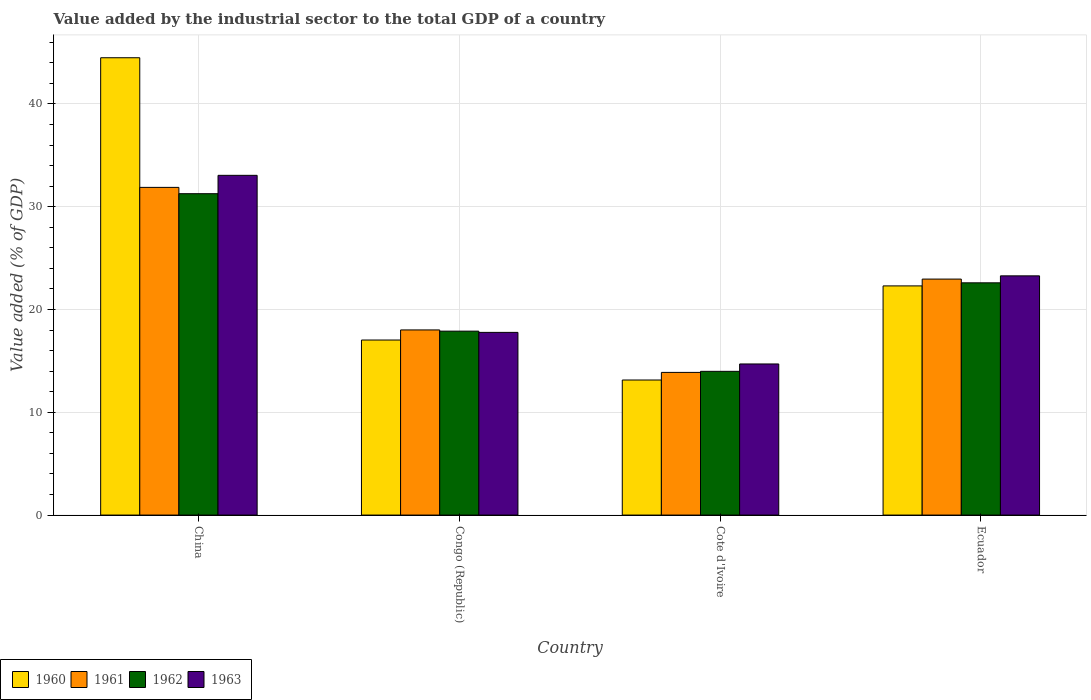How many different coloured bars are there?
Your response must be concise. 4. How many groups of bars are there?
Keep it short and to the point. 4. Are the number of bars on each tick of the X-axis equal?
Your answer should be very brief. Yes. What is the label of the 3rd group of bars from the left?
Your response must be concise. Cote d'Ivoire. What is the value added by the industrial sector to the total GDP in 1960 in Ecuador?
Offer a very short reply. 22.29. Across all countries, what is the maximum value added by the industrial sector to the total GDP in 1960?
Offer a terse response. 44.49. Across all countries, what is the minimum value added by the industrial sector to the total GDP in 1961?
Offer a terse response. 13.88. In which country was the value added by the industrial sector to the total GDP in 1963 minimum?
Ensure brevity in your answer.  Cote d'Ivoire. What is the total value added by the industrial sector to the total GDP in 1963 in the graph?
Your answer should be very brief. 88.79. What is the difference between the value added by the industrial sector to the total GDP in 1960 in Congo (Republic) and that in Ecuador?
Make the answer very short. -5.27. What is the difference between the value added by the industrial sector to the total GDP in 1962 in Congo (Republic) and the value added by the industrial sector to the total GDP in 1960 in Ecuador?
Your answer should be compact. -4.4. What is the average value added by the industrial sector to the total GDP in 1963 per country?
Your response must be concise. 22.2. What is the difference between the value added by the industrial sector to the total GDP of/in 1963 and value added by the industrial sector to the total GDP of/in 1962 in China?
Provide a succinct answer. 1.79. In how many countries, is the value added by the industrial sector to the total GDP in 1960 greater than 30 %?
Keep it short and to the point. 1. What is the ratio of the value added by the industrial sector to the total GDP in 1961 in Congo (Republic) to that in Cote d'Ivoire?
Your answer should be very brief. 1.3. Is the value added by the industrial sector to the total GDP in 1960 in China less than that in Ecuador?
Your answer should be very brief. No. Is the difference between the value added by the industrial sector to the total GDP in 1963 in China and Cote d'Ivoire greater than the difference between the value added by the industrial sector to the total GDP in 1962 in China and Cote d'Ivoire?
Your answer should be very brief. Yes. What is the difference between the highest and the second highest value added by the industrial sector to the total GDP in 1960?
Provide a succinct answer. -27.46. What is the difference between the highest and the lowest value added by the industrial sector to the total GDP in 1963?
Your answer should be very brief. 18.35. In how many countries, is the value added by the industrial sector to the total GDP in 1961 greater than the average value added by the industrial sector to the total GDP in 1961 taken over all countries?
Keep it short and to the point. 2. What does the 2nd bar from the right in Ecuador represents?
Make the answer very short. 1962. Is it the case that in every country, the sum of the value added by the industrial sector to the total GDP in 1963 and value added by the industrial sector to the total GDP in 1961 is greater than the value added by the industrial sector to the total GDP in 1960?
Make the answer very short. Yes. How many bars are there?
Your answer should be compact. 16. What is the difference between two consecutive major ticks on the Y-axis?
Ensure brevity in your answer.  10. How many legend labels are there?
Offer a terse response. 4. What is the title of the graph?
Offer a very short reply. Value added by the industrial sector to the total GDP of a country. Does "1997" appear as one of the legend labels in the graph?
Your answer should be compact. No. What is the label or title of the X-axis?
Ensure brevity in your answer.  Country. What is the label or title of the Y-axis?
Provide a succinct answer. Value added (% of GDP). What is the Value added (% of GDP) in 1960 in China?
Your answer should be compact. 44.49. What is the Value added (% of GDP) of 1961 in China?
Your answer should be compact. 31.88. What is the Value added (% of GDP) in 1962 in China?
Provide a succinct answer. 31.26. What is the Value added (% of GDP) of 1963 in China?
Give a very brief answer. 33.05. What is the Value added (% of GDP) in 1960 in Congo (Republic)?
Your answer should be very brief. 17.03. What is the Value added (% of GDP) of 1961 in Congo (Republic)?
Make the answer very short. 18.01. What is the Value added (% of GDP) of 1962 in Congo (Republic)?
Your answer should be very brief. 17.89. What is the Value added (% of GDP) of 1963 in Congo (Republic)?
Give a very brief answer. 17.77. What is the Value added (% of GDP) in 1960 in Cote d'Ivoire?
Make the answer very short. 13.14. What is the Value added (% of GDP) of 1961 in Cote d'Ivoire?
Give a very brief answer. 13.88. What is the Value added (% of GDP) of 1962 in Cote d'Ivoire?
Your response must be concise. 13.98. What is the Value added (% of GDP) in 1963 in Cote d'Ivoire?
Give a very brief answer. 14.7. What is the Value added (% of GDP) of 1960 in Ecuador?
Provide a short and direct response. 22.29. What is the Value added (% of GDP) in 1961 in Ecuador?
Give a very brief answer. 22.96. What is the Value added (% of GDP) of 1962 in Ecuador?
Your answer should be very brief. 22.59. What is the Value added (% of GDP) of 1963 in Ecuador?
Give a very brief answer. 23.27. Across all countries, what is the maximum Value added (% of GDP) in 1960?
Provide a short and direct response. 44.49. Across all countries, what is the maximum Value added (% of GDP) of 1961?
Give a very brief answer. 31.88. Across all countries, what is the maximum Value added (% of GDP) in 1962?
Provide a succinct answer. 31.26. Across all countries, what is the maximum Value added (% of GDP) in 1963?
Keep it short and to the point. 33.05. Across all countries, what is the minimum Value added (% of GDP) of 1960?
Offer a terse response. 13.14. Across all countries, what is the minimum Value added (% of GDP) in 1961?
Offer a terse response. 13.88. Across all countries, what is the minimum Value added (% of GDP) in 1962?
Your answer should be compact. 13.98. Across all countries, what is the minimum Value added (% of GDP) of 1963?
Provide a short and direct response. 14.7. What is the total Value added (% of GDP) in 1960 in the graph?
Offer a very short reply. 96.95. What is the total Value added (% of GDP) in 1961 in the graph?
Keep it short and to the point. 86.72. What is the total Value added (% of GDP) of 1962 in the graph?
Provide a succinct answer. 85.73. What is the total Value added (% of GDP) of 1963 in the graph?
Your answer should be compact. 88.79. What is the difference between the Value added (% of GDP) of 1960 in China and that in Congo (Republic)?
Offer a very short reply. 27.46. What is the difference between the Value added (% of GDP) of 1961 in China and that in Congo (Republic)?
Make the answer very short. 13.87. What is the difference between the Value added (% of GDP) of 1962 in China and that in Congo (Republic)?
Your answer should be very brief. 13.37. What is the difference between the Value added (% of GDP) in 1963 in China and that in Congo (Republic)?
Ensure brevity in your answer.  15.28. What is the difference between the Value added (% of GDP) in 1960 in China and that in Cote d'Ivoire?
Offer a very short reply. 31.35. What is the difference between the Value added (% of GDP) in 1961 in China and that in Cote d'Ivoire?
Offer a very short reply. 18. What is the difference between the Value added (% of GDP) of 1962 in China and that in Cote d'Ivoire?
Provide a succinct answer. 17.28. What is the difference between the Value added (% of GDP) of 1963 in China and that in Cote d'Ivoire?
Provide a short and direct response. 18.35. What is the difference between the Value added (% of GDP) in 1960 in China and that in Ecuador?
Give a very brief answer. 22.19. What is the difference between the Value added (% of GDP) in 1961 in China and that in Ecuador?
Keep it short and to the point. 8.92. What is the difference between the Value added (% of GDP) of 1962 in China and that in Ecuador?
Your answer should be compact. 8.67. What is the difference between the Value added (% of GDP) of 1963 in China and that in Ecuador?
Offer a terse response. 9.78. What is the difference between the Value added (% of GDP) in 1960 in Congo (Republic) and that in Cote d'Ivoire?
Keep it short and to the point. 3.89. What is the difference between the Value added (% of GDP) in 1961 in Congo (Republic) and that in Cote d'Ivoire?
Offer a very short reply. 4.13. What is the difference between the Value added (% of GDP) of 1962 in Congo (Republic) and that in Cote d'Ivoire?
Make the answer very short. 3.91. What is the difference between the Value added (% of GDP) in 1963 in Congo (Republic) and that in Cote d'Ivoire?
Keep it short and to the point. 3.07. What is the difference between the Value added (% of GDP) in 1960 in Congo (Republic) and that in Ecuador?
Ensure brevity in your answer.  -5.27. What is the difference between the Value added (% of GDP) in 1961 in Congo (Republic) and that in Ecuador?
Offer a very short reply. -4.95. What is the difference between the Value added (% of GDP) of 1962 in Congo (Republic) and that in Ecuador?
Offer a terse response. -4.7. What is the difference between the Value added (% of GDP) in 1963 in Congo (Republic) and that in Ecuador?
Ensure brevity in your answer.  -5.5. What is the difference between the Value added (% of GDP) in 1960 in Cote d'Ivoire and that in Ecuador?
Give a very brief answer. -9.16. What is the difference between the Value added (% of GDP) in 1961 in Cote d'Ivoire and that in Ecuador?
Make the answer very short. -9.08. What is the difference between the Value added (% of GDP) of 1962 in Cote d'Ivoire and that in Ecuador?
Offer a very short reply. -8.61. What is the difference between the Value added (% of GDP) in 1963 in Cote d'Ivoire and that in Ecuador?
Offer a terse response. -8.57. What is the difference between the Value added (% of GDP) in 1960 in China and the Value added (% of GDP) in 1961 in Congo (Republic)?
Provide a short and direct response. 26.48. What is the difference between the Value added (% of GDP) of 1960 in China and the Value added (% of GDP) of 1962 in Congo (Republic)?
Your answer should be very brief. 26.6. What is the difference between the Value added (% of GDP) of 1960 in China and the Value added (% of GDP) of 1963 in Congo (Republic)?
Ensure brevity in your answer.  26.72. What is the difference between the Value added (% of GDP) in 1961 in China and the Value added (% of GDP) in 1962 in Congo (Republic)?
Your answer should be very brief. 13.98. What is the difference between the Value added (% of GDP) of 1961 in China and the Value added (% of GDP) of 1963 in Congo (Republic)?
Provide a succinct answer. 14.1. What is the difference between the Value added (% of GDP) in 1962 in China and the Value added (% of GDP) in 1963 in Congo (Republic)?
Your response must be concise. 13.49. What is the difference between the Value added (% of GDP) in 1960 in China and the Value added (% of GDP) in 1961 in Cote d'Ivoire?
Your answer should be compact. 30.61. What is the difference between the Value added (% of GDP) in 1960 in China and the Value added (% of GDP) in 1962 in Cote d'Ivoire?
Offer a terse response. 30.51. What is the difference between the Value added (% of GDP) of 1960 in China and the Value added (% of GDP) of 1963 in Cote d'Ivoire?
Your answer should be compact. 29.79. What is the difference between the Value added (% of GDP) of 1961 in China and the Value added (% of GDP) of 1962 in Cote d'Ivoire?
Provide a succinct answer. 17.9. What is the difference between the Value added (% of GDP) in 1961 in China and the Value added (% of GDP) in 1963 in Cote d'Ivoire?
Provide a succinct answer. 17.18. What is the difference between the Value added (% of GDP) in 1962 in China and the Value added (% of GDP) in 1963 in Cote d'Ivoire?
Your answer should be compact. 16.56. What is the difference between the Value added (% of GDP) of 1960 in China and the Value added (% of GDP) of 1961 in Ecuador?
Your answer should be compact. 21.53. What is the difference between the Value added (% of GDP) of 1960 in China and the Value added (% of GDP) of 1962 in Ecuador?
Your answer should be very brief. 21.9. What is the difference between the Value added (% of GDP) of 1960 in China and the Value added (% of GDP) of 1963 in Ecuador?
Your response must be concise. 21.22. What is the difference between the Value added (% of GDP) in 1961 in China and the Value added (% of GDP) in 1962 in Ecuador?
Your response must be concise. 9.28. What is the difference between the Value added (% of GDP) of 1961 in China and the Value added (% of GDP) of 1963 in Ecuador?
Keep it short and to the point. 8.61. What is the difference between the Value added (% of GDP) in 1962 in China and the Value added (% of GDP) in 1963 in Ecuador?
Provide a succinct answer. 7.99. What is the difference between the Value added (% of GDP) of 1960 in Congo (Republic) and the Value added (% of GDP) of 1961 in Cote d'Ivoire?
Your answer should be compact. 3.15. What is the difference between the Value added (% of GDP) of 1960 in Congo (Republic) and the Value added (% of GDP) of 1962 in Cote d'Ivoire?
Give a very brief answer. 3.05. What is the difference between the Value added (% of GDP) of 1960 in Congo (Republic) and the Value added (% of GDP) of 1963 in Cote d'Ivoire?
Provide a succinct answer. 2.33. What is the difference between the Value added (% of GDP) of 1961 in Congo (Republic) and the Value added (% of GDP) of 1962 in Cote d'Ivoire?
Provide a short and direct response. 4.03. What is the difference between the Value added (% of GDP) of 1961 in Congo (Republic) and the Value added (% of GDP) of 1963 in Cote d'Ivoire?
Offer a terse response. 3.31. What is the difference between the Value added (% of GDP) of 1962 in Congo (Republic) and the Value added (% of GDP) of 1963 in Cote d'Ivoire?
Your answer should be very brief. 3.19. What is the difference between the Value added (% of GDP) of 1960 in Congo (Republic) and the Value added (% of GDP) of 1961 in Ecuador?
Give a very brief answer. -5.93. What is the difference between the Value added (% of GDP) in 1960 in Congo (Republic) and the Value added (% of GDP) in 1962 in Ecuador?
Your answer should be compact. -5.57. What is the difference between the Value added (% of GDP) of 1960 in Congo (Republic) and the Value added (% of GDP) of 1963 in Ecuador?
Your answer should be compact. -6.24. What is the difference between the Value added (% of GDP) of 1961 in Congo (Republic) and the Value added (% of GDP) of 1962 in Ecuador?
Make the answer very short. -4.58. What is the difference between the Value added (% of GDP) in 1961 in Congo (Republic) and the Value added (% of GDP) in 1963 in Ecuador?
Keep it short and to the point. -5.26. What is the difference between the Value added (% of GDP) of 1962 in Congo (Republic) and the Value added (% of GDP) of 1963 in Ecuador?
Your answer should be compact. -5.38. What is the difference between the Value added (% of GDP) in 1960 in Cote d'Ivoire and the Value added (% of GDP) in 1961 in Ecuador?
Your answer should be very brief. -9.82. What is the difference between the Value added (% of GDP) of 1960 in Cote d'Ivoire and the Value added (% of GDP) of 1962 in Ecuador?
Keep it short and to the point. -9.45. What is the difference between the Value added (% of GDP) of 1960 in Cote d'Ivoire and the Value added (% of GDP) of 1963 in Ecuador?
Keep it short and to the point. -10.13. What is the difference between the Value added (% of GDP) of 1961 in Cote d'Ivoire and the Value added (% of GDP) of 1962 in Ecuador?
Your answer should be very brief. -8.71. What is the difference between the Value added (% of GDP) of 1961 in Cote d'Ivoire and the Value added (% of GDP) of 1963 in Ecuador?
Offer a terse response. -9.39. What is the difference between the Value added (% of GDP) in 1962 in Cote d'Ivoire and the Value added (% of GDP) in 1963 in Ecuador?
Make the answer very short. -9.29. What is the average Value added (% of GDP) of 1960 per country?
Your answer should be compact. 24.24. What is the average Value added (% of GDP) in 1961 per country?
Give a very brief answer. 21.68. What is the average Value added (% of GDP) of 1962 per country?
Make the answer very short. 21.43. What is the average Value added (% of GDP) in 1963 per country?
Your answer should be compact. 22.2. What is the difference between the Value added (% of GDP) in 1960 and Value added (% of GDP) in 1961 in China?
Provide a short and direct response. 12.61. What is the difference between the Value added (% of GDP) in 1960 and Value added (% of GDP) in 1962 in China?
Your answer should be very brief. 13.23. What is the difference between the Value added (% of GDP) in 1960 and Value added (% of GDP) in 1963 in China?
Your answer should be very brief. 11.44. What is the difference between the Value added (% of GDP) of 1961 and Value added (% of GDP) of 1962 in China?
Provide a short and direct response. 0.61. What is the difference between the Value added (% of GDP) in 1961 and Value added (% of GDP) in 1963 in China?
Your answer should be very brief. -1.17. What is the difference between the Value added (% of GDP) of 1962 and Value added (% of GDP) of 1963 in China?
Give a very brief answer. -1.79. What is the difference between the Value added (% of GDP) of 1960 and Value added (% of GDP) of 1961 in Congo (Republic)?
Give a very brief answer. -0.98. What is the difference between the Value added (% of GDP) in 1960 and Value added (% of GDP) in 1962 in Congo (Republic)?
Your response must be concise. -0.86. What is the difference between the Value added (% of GDP) in 1960 and Value added (% of GDP) in 1963 in Congo (Republic)?
Provide a succinct answer. -0.74. What is the difference between the Value added (% of GDP) of 1961 and Value added (% of GDP) of 1962 in Congo (Republic)?
Your response must be concise. 0.12. What is the difference between the Value added (% of GDP) in 1961 and Value added (% of GDP) in 1963 in Congo (Republic)?
Give a very brief answer. 0.24. What is the difference between the Value added (% of GDP) of 1962 and Value added (% of GDP) of 1963 in Congo (Republic)?
Ensure brevity in your answer.  0.12. What is the difference between the Value added (% of GDP) of 1960 and Value added (% of GDP) of 1961 in Cote d'Ivoire?
Give a very brief answer. -0.74. What is the difference between the Value added (% of GDP) of 1960 and Value added (% of GDP) of 1962 in Cote d'Ivoire?
Give a very brief answer. -0.84. What is the difference between the Value added (% of GDP) of 1960 and Value added (% of GDP) of 1963 in Cote d'Ivoire?
Give a very brief answer. -1.56. What is the difference between the Value added (% of GDP) in 1961 and Value added (% of GDP) in 1962 in Cote d'Ivoire?
Your response must be concise. -0.1. What is the difference between the Value added (% of GDP) of 1961 and Value added (% of GDP) of 1963 in Cote d'Ivoire?
Make the answer very short. -0.82. What is the difference between the Value added (% of GDP) in 1962 and Value added (% of GDP) in 1963 in Cote d'Ivoire?
Ensure brevity in your answer.  -0.72. What is the difference between the Value added (% of GDP) in 1960 and Value added (% of GDP) in 1961 in Ecuador?
Your response must be concise. -0.66. What is the difference between the Value added (% of GDP) in 1960 and Value added (% of GDP) in 1962 in Ecuador?
Offer a terse response. -0.3. What is the difference between the Value added (% of GDP) in 1960 and Value added (% of GDP) in 1963 in Ecuador?
Your response must be concise. -0.98. What is the difference between the Value added (% of GDP) of 1961 and Value added (% of GDP) of 1962 in Ecuador?
Ensure brevity in your answer.  0.36. What is the difference between the Value added (% of GDP) of 1961 and Value added (% of GDP) of 1963 in Ecuador?
Provide a short and direct response. -0.31. What is the difference between the Value added (% of GDP) in 1962 and Value added (% of GDP) in 1963 in Ecuador?
Provide a succinct answer. -0.68. What is the ratio of the Value added (% of GDP) of 1960 in China to that in Congo (Republic)?
Your answer should be very brief. 2.61. What is the ratio of the Value added (% of GDP) in 1961 in China to that in Congo (Republic)?
Your answer should be compact. 1.77. What is the ratio of the Value added (% of GDP) in 1962 in China to that in Congo (Republic)?
Your response must be concise. 1.75. What is the ratio of the Value added (% of GDP) of 1963 in China to that in Congo (Republic)?
Offer a very short reply. 1.86. What is the ratio of the Value added (% of GDP) of 1960 in China to that in Cote d'Ivoire?
Provide a succinct answer. 3.39. What is the ratio of the Value added (% of GDP) in 1961 in China to that in Cote d'Ivoire?
Your answer should be very brief. 2.3. What is the ratio of the Value added (% of GDP) in 1962 in China to that in Cote d'Ivoire?
Ensure brevity in your answer.  2.24. What is the ratio of the Value added (% of GDP) of 1963 in China to that in Cote d'Ivoire?
Offer a terse response. 2.25. What is the ratio of the Value added (% of GDP) in 1960 in China to that in Ecuador?
Provide a succinct answer. 2. What is the ratio of the Value added (% of GDP) of 1961 in China to that in Ecuador?
Your answer should be very brief. 1.39. What is the ratio of the Value added (% of GDP) of 1962 in China to that in Ecuador?
Your response must be concise. 1.38. What is the ratio of the Value added (% of GDP) in 1963 in China to that in Ecuador?
Offer a terse response. 1.42. What is the ratio of the Value added (% of GDP) of 1960 in Congo (Republic) to that in Cote d'Ivoire?
Provide a short and direct response. 1.3. What is the ratio of the Value added (% of GDP) of 1961 in Congo (Republic) to that in Cote d'Ivoire?
Ensure brevity in your answer.  1.3. What is the ratio of the Value added (% of GDP) in 1962 in Congo (Republic) to that in Cote d'Ivoire?
Keep it short and to the point. 1.28. What is the ratio of the Value added (% of GDP) of 1963 in Congo (Republic) to that in Cote d'Ivoire?
Keep it short and to the point. 1.21. What is the ratio of the Value added (% of GDP) of 1960 in Congo (Republic) to that in Ecuador?
Provide a short and direct response. 0.76. What is the ratio of the Value added (% of GDP) of 1961 in Congo (Republic) to that in Ecuador?
Provide a short and direct response. 0.78. What is the ratio of the Value added (% of GDP) in 1962 in Congo (Republic) to that in Ecuador?
Keep it short and to the point. 0.79. What is the ratio of the Value added (% of GDP) of 1963 in Congo (Republic) to that in Ecuador?
Make the answer very short. 0.76. What is the ratio of the Value added (% of GDP) in 1960 in Cote d'Ivoire to that in Ecuador?
Give a very brief answer. 0.59. What is the ratio of the Value added (% of GDP) in 1961 in Cote d'Ivoire to that in Ecuador?
Offer a terse response. 0.6. What is the ratio of the Value added (% of GDP) of 1962 in Cote d'Ivoire to that in Ecuador?
Ensure brevity in your answer.  0.62. What is the ratio of the Value added (% of GDP) of 1963 in Cote d'Ivoire to that in Ecuador?
Your answer should be compact. 0.63. What is the difference between the highest and the second highest Value added (% of GDP) of 1960?
Your answer should be very brief. 22.19. What is the difference between the highest and the second highest Value added (% of GDP) of 1961?
Offer a very short reply. 8.92. What is the difference between the highest and the second highest Value added (% of GDP) in 1962?
Provide a short and direct response. 8.67. What is the difference between the highest and the second highest Value added (% of GDP) in 1963?
Your answer should be compact. 9.78. What is the difference between the highest and the lowest Value added (% of GDP) of 1960?
Provide a succinct answer. 31.35. What is the difference between the highest and the lowest Value added (% of GDP) of 1961?
Provide a short and direct response. 18. What is the difference between the highest and the lowest Value added (% of GDP) of 1962?
Provide a short and direct response. 17.28. What is the difference between the highest and the lowest Value added (% of GDP) of 1963?
Your answer should be very brief. 18.35. 